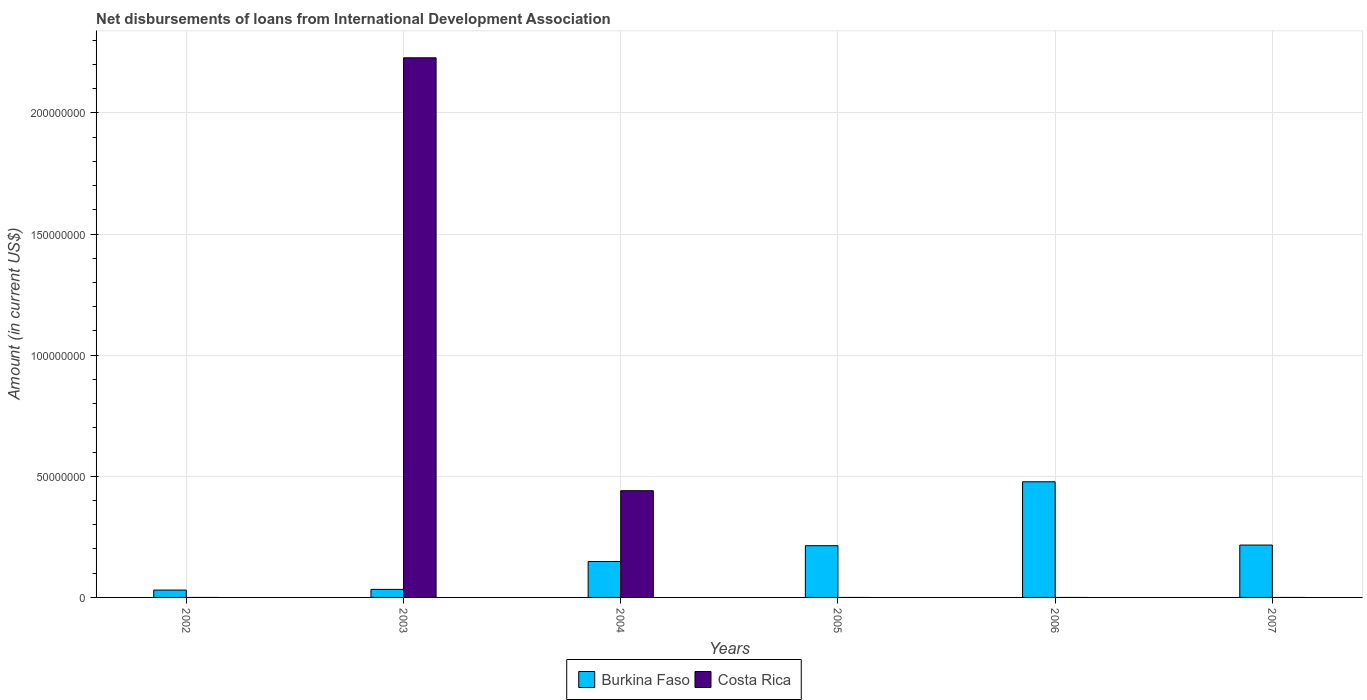How many different coloured bars are there?
Offer a terse response. 2. How many bars are there on the 4th tick from the right?
Offer a very short reply. 2. What is the label of the 3rd group of bars from the left?
Ensure brevity in your answer.  2004. What is the amount of loans disbursed in Burkina Faso in 2003?
Provide a succinct answer. 3.32e+06. Across all years, what is the maximum amount of loans disbursed in Burkina Faso?
Ensure brevity in your answer.  4.77e+07. Across all years, what is the minimum amount of loans disbursed in Burkina Faso?
Make the answer very short. 3.04e+06. In which year was the amount of loans disbursed in Burkina Faso maximum?
Offer a terse response. 2006. What is the total amount of loans disbursed in Costa Rica in the graph?
Your answer should be compact. 2.67e+08. What is the difference between the amount of loans disbursed in Burkina Faso in 2002 and that in 2007?
Provide a succinct answer. -1.86e+07. What is the difference between the amount of loans disbursed in Burkina Faso in 2007 and the amount of loans disbursed in Costa Rica in 2003?
Give a very brief answer. -2.01e+08. What is the average amount of loans disbursed in Burkina Faso per year?
Provide a succinct answer. 1.86e+07. In how many years, is the amount of loans disbursed in Costa Rica greater than 20000000 US$?
Offer a very short reply. 2. What is the ratio of the amount of loans disbursed in Burkina Faso in 2003 to that in 2004?
Give a very brief answer. 0.22. Is the amount of loans disbursed in Burkina Faso in 2002 less than that in 2005?
Make the answer very short. Yes. What is the difference between the highest and the second highest amount of loans disbursed in Burkina Faso?
Your response must be concise. 2.61e+07. What is the difference between the highest and the lowest amount of loans disbursed in Costa Rica?
Make the answer very short. 2.23e+08. How many bars are there?
Provide a succinct answer. 8. Are all the bars in the graph horizontal?
Keep it short and to the point. No. Does the graph contain any zero values?
Offer a terse response. Yes. How are the legend labels stacked?
Your answer should be very brief. Horizontal. What is the title of the graph?
Offer a terse response. Net disbursements of loans from International Development Association. Does "United States" appear as one of the legend labels in the graph?
Offer a terse response. No. What is the label or title of the X-axis?
Offer a very short reply. Years. What is the label or title of the Y-axis?
Your response must be concise. Amount (in current US$). What is the Amount (in current US$) of Burkina Faso in 2002?
Make the answer very short. 3.04e+06. What is the Amount (in current US$) of Costa Rica in 2002?
Your response must be concise. 0. What is the Amount (in current US$) of Burkina Faso in 2003?
Offer a terse response. 3.32e+06. What is the Amount (in current US$) in Costa Rica in 2003?
Your response must be concise. 2.23e+08. What is the Amount (in current US$) of Burkina Faso in 2004?
Provide a short and direct response. 1.48e+07. What is the Amount (in current US$) of Costa Rica in 2004?
Keep it short and to the point. 4.41e+07. What is the Amount (in current US$) of Burkina Faso in 2005?
Provide a succinct answer. 2.13e+07. What is the Amount (in current US$) in Costa Rica in 2005?
Your response must be concise. 0. What is the Amount (in current US$) of Burkina Faso in 2006?
Provide a short and direct response. 4.77e+07. What is the Amount (in current US$) of Costa Rica in 2006?
Your answer should be compact. 0. What is the Amount (in current US$) of Burkina Faso in 2007?
Provide a short and direct response. 2.16e+07. What is the Amount (in current US$) of Costa Rica in 2007?
Ensure brevity in your answer.  0. Across all years, what is the maximum Amount (in current US$) of Burkina Faso?
Offer a very short reply. 4.77e+07. Across all years, what is the maximum Amount (in current US$) of Costa Rica?
Make the answer very short. 2.23e+08. Across all years, what is the minimum Amount (in current US$) in Burkina Faso?
Your answer should be very brief. 3.04e+06. What is the total Amount (in current US$) of Burkina Faso in the graph?
Your response must be concise. 1.12e+08. What is the total Amount (in current US$) in Costa Rica in the graph?
Keep it short and to the point. 2.67e+08. What is the difference between the Amount (in current US$) of Burkina Faso in 2002 and that in 2003?
Provide a short and direct response. -2.82e+05. What is the difference between the Amount (in current US$) in Burkina Faso in 2002 and that in 2004?
Make the answer very short. -1.18e+07. What is the difference between the Amount (in current US$) in Burkina Faso in 2002 and that in 2005?
Your answer should be compact. -1.83e+07. What is the difference between the Amount (in current US$) of Burkina Faso in 2002 and that in 2006?
Provide a short and direct response. -4.47e+07. What is the difference between the Amount (in current US$) of Burkina Faso in 2002 and that in 2007?
Your answer should be very brief. -1.86e+07. What is the difference between the Amount (in current US$) in Burkina Faso in 2003 and that in 2004?
Ensure brevity in your answer.  -1.15e+07. What is the difference between the Amount (in current US$) of Costa Rica in 2003 and that in 2004?
Provide a succinct answer. 1.79e+08. What is the difference between the Amount (in current US$) of Burkina Faso in 2003 and that in 2005?
Offer a terse response. -1.80e+07. What is the difference between the Amount (in current US$) in Burkina Faso in 2003 and that in 2006?
Offer a very short reply. -4.44e+07. What is the difference between the Amount (in current US$) of Burkina Faso in 2003 and that in 2007?
Provide a short and direct response. -1.83e+07. What is the difference between the Amount (in current US$) in Burkina Faso in 2004 and that in 2005?
Your answer should be compact. -6.52e+06. What is the difference between the Amount (in current US$) of Burkina Faso in 2004 and that in 2006?
Your response must be concise. -3.29e+07. What is the difference between the Amount (in current US$) of Burkina Faso in 2004 and that in 2007?
Keep it short and to the point. -6.79e+06. What is the difference between the Amount (in current US$) of Burkina Faso in 2005 and that in 2006?
Provide a succinct answer. -2.64e+07. What is the difference between the Amount (in current US$) in Burkina Faso in 2005 and that in 2007?
Offer a terse response. -2.67e+05. What is the difference between the Amount (in current US$) of Burkina Faso in 2006 and that in 2007?
Offer a very short reply. 2.61e+07. What is the difference between the Amount (in current US$) in Burkina Faso in 2002 and the Amount (in current US$) in Costa Rica in 2003?
Your answer should be very brief. -2.20e+08. What is the difference between the Amount (in current US$) in Burkina Faso in 2002 and the Amount (in current US$) in Costa Rica in 2004?
Provide a short and direct response. -4.10e+07. What is the difference between the Amount (in current US$) of Burkina Faso in 2003 and the Amount (in current US$) of Costa Rica in 2004?
Keep it short and to the point. -4.07e+07. What is the average Amount (in current US$) in Burkina Faso per year?
Provide a succinct answer. 1.86e+07. What is the average Amount (in current US$) in Costa Rica per year?
Provide a succinct answer. 4.45e+07. In the year 2003, what is the difference between the Amount (in current US$) of Burkina Faso and Amount (in current US$) of Costa Rica?
Keep it short and to the point. -2.19e+08. In the year 2004, what is the difference between the Amount (in current US$) of Burkina Faso and Amount (in current US$) of Costa Rica?
Provide a succinct answer. -2.92e+07. What is the ratio of the Amount (in current US$) of Burkina Faso in 2002 to that in 2003?
Give a very brief answer. 0.92. What is the ratio of the Amount (in current US$) in Burkina Faso in 2002 to that in 2004?
Provide a short and direct response. 0.2. What is the ratio of the Amount (in current US$) of Burkina Faso in 2002 to that in 2005?
Give a very brief answer. 0.14. What is the ratio of the Amount (in current US$) in Burkina Faso in 2002 to that in 2006?
Your answer should be compact. 0.06. What is the ratio of the Amount (in current US$) of Burkina Faso in 2002 to that in 2007?
Your response must be concise. 0.14. What is the ratio of the Amount (in current US$) in Burkina Faso in 2003 to that in 2004?
Your answer should be very brief. 0.22. What is the ratio of the Amount (in current US$) in Costa Rica in 2003 to that in 2004?
Ensure brevity in your answer.  5.06. What is the ratio of the Amount (in current US$) in Burkina Faso in 2003 to that in 2005?
Make the answer very short. 0.16. What is the ratio of the Amount (in current US$) of Burkina Faso in 2003 to that in 2006?
Provide a succinct answer. 0.07. What is the ratio of the Amount (in current US$) in Burkina Faso in 2003 to that in 2007?
Give a very brief answer. 0.15. What is the ratio of the Amount (in current US$) of Burkina Faso in 2004 to that in 2005?
Provide a succinct answer. 0.69. What is the ratio of the Amount (in current US$) of Burkina Faso in 2004 to that in 2006?
Offer a very short reply. 0.31. What is the ratio of the Amount (in current US$) in Burkina Faso in 2004 to that in 2007?
Provide a short and direct response. 0.69. What is the ratio of the Amount (in current US$) in Burkina Faso in 2005 to that in 2006?
Offer a terse response. 0.45. What is the ratio of the Amount (in current US$) in Burkina Faso in 2005 to that in 2007?
Your response must be concise. 0.99. What is the ratio of the Amount (in current US$) in Burkina Faso in 2006 to that in 2007?
Your response must be concise. 2.21. What is the difference between the highest and the second highest Amount (in current US$) in Burkina Faso?
Ensure brevity in your answer.  2.61e+07. What is the difference between the highest and the lowest Amount (in current US$) of Burkina Faso?
Keep it short and to the point. 4.47e+07. What is the difference between the highest and the lowest Amount (in current US$) in Costa Rica?
Offer a very short reply. 2.23e+08. 